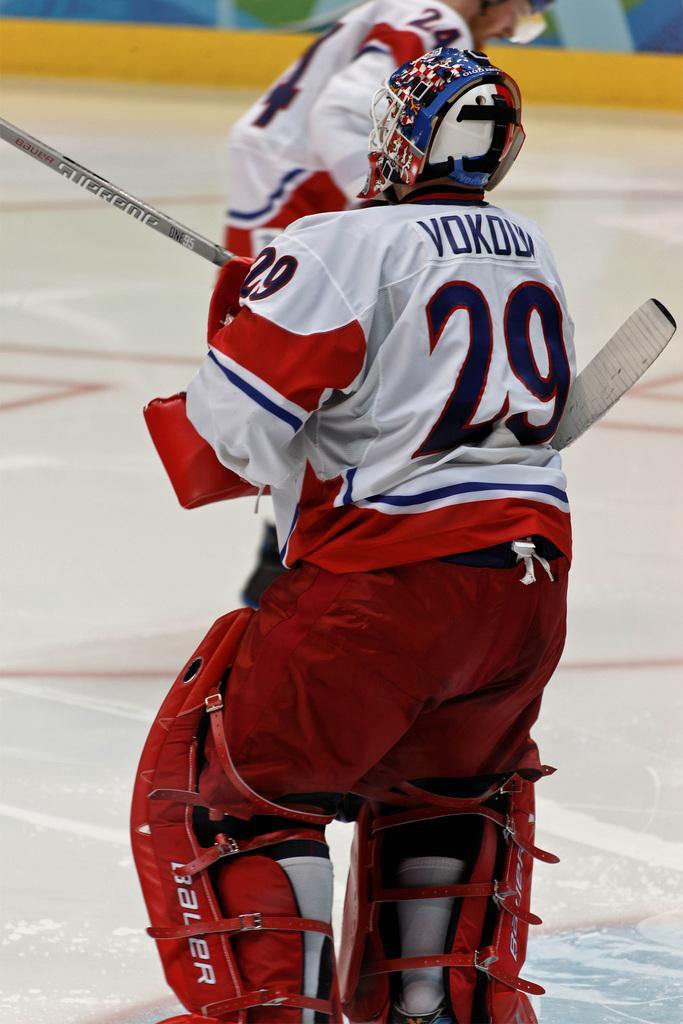What is the person in the foreground of the image holding? The person is holding a stick in the image. What type of protective gear is the person wearing? The person is wearing a helmet. Can you describe the background of the image? There is another person visible in the background of the image, and there is a floor. Is the minister shaking hands with the person in the image? There is no minister or handshake present in the image. 